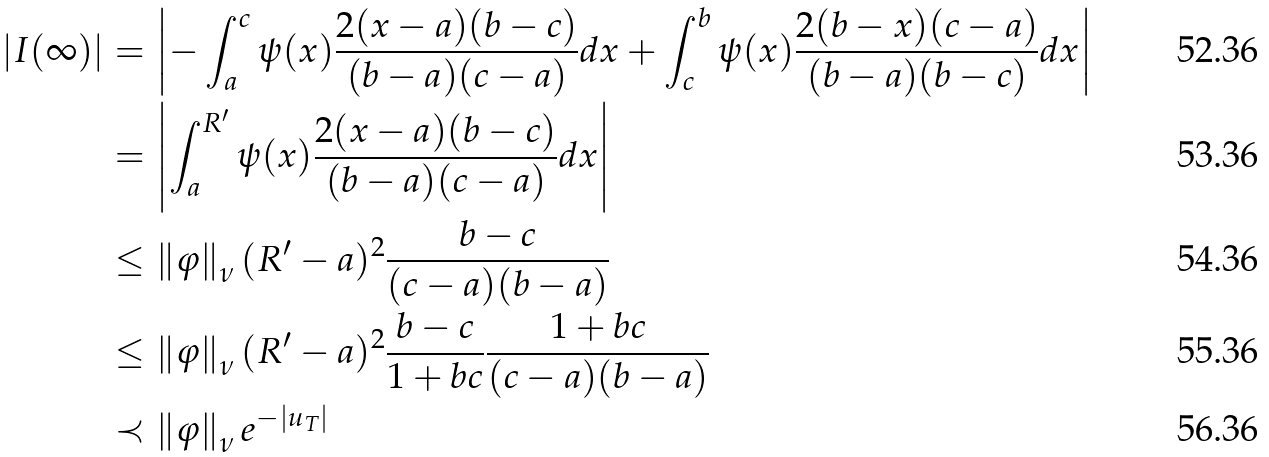<formula> <loc_0><loc_0><loc_500><loc_500>\left | I ( \infty ) \right | & = \left | - \int _ { a } ^ { c } \psi ( x ) \frac { 2 ( x - a ) ( b - c ) } { ( b - a ) ( c - a ) } d x + \int _ { c } ^ { b } \psi ( x ) \frac { 2 ( b - x ) ( c - a ) } { ( b - a ) ( b - c ) } d x \right | \\ & = \left | \int _ { a } ^ { R ^ { \prime } } \psi ( x ) \frac { 2 ( x - a ) ( b - c ) } { ( b - a ) ( c - a ) } d x \right | \\ & \leq \left \| \varphi \right \| _ { \nu } ( R ^ { \prime } - a ) ^ { 2 } \frac { b - c } { ( c - a ) ( b - a ) } \\ & \leq \left \| \varphi \right \| _ { \nu } ( R ^ { \prime } - a ) ^ { 2 } \frac { b - c } { 1 + b c } \frac { 1 + b c } { ( c - a ) ( b - a ) } \\ & \prec \left \| \varphi \right \| _ { \nu } e ^ { - \left | u _ { T } \right | }</formula> 